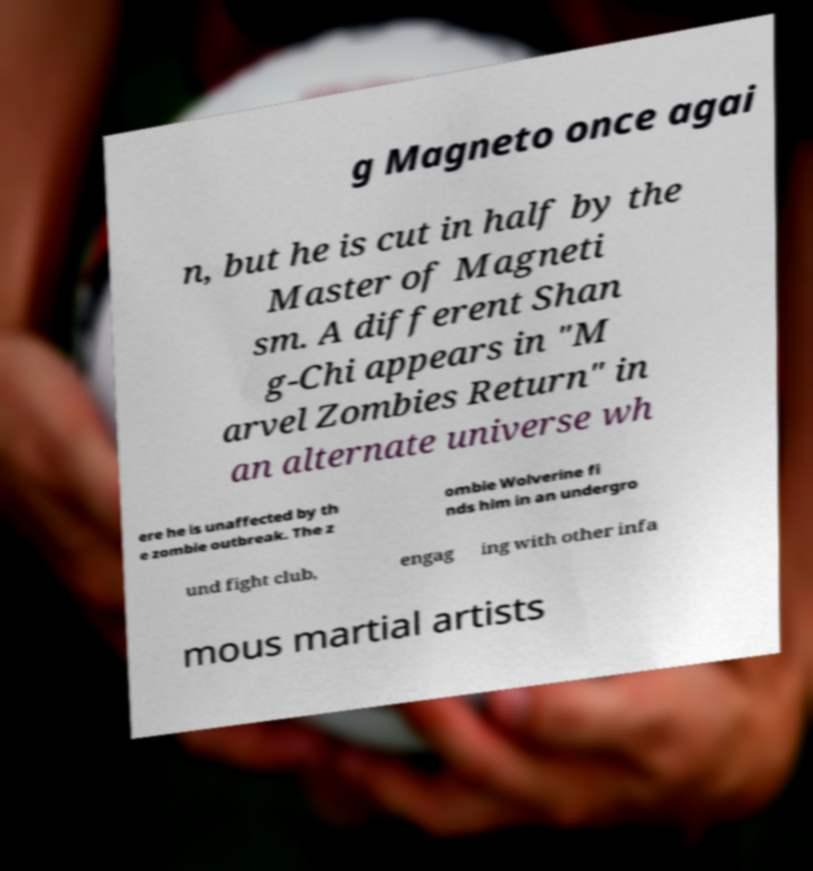Could you extract and type out the text from this image? g Magneto once agai n, but he is cut in half by the Master of Magneti sm. A different Shan g-Chi appears in "M arvel Zombies Return" in an alternate universe wh ere he is unaffected by th e zombie outbreak. The z ombie Wolverine fi nds him in an undergro und fight club, engag ing with other infa mous martial artists 